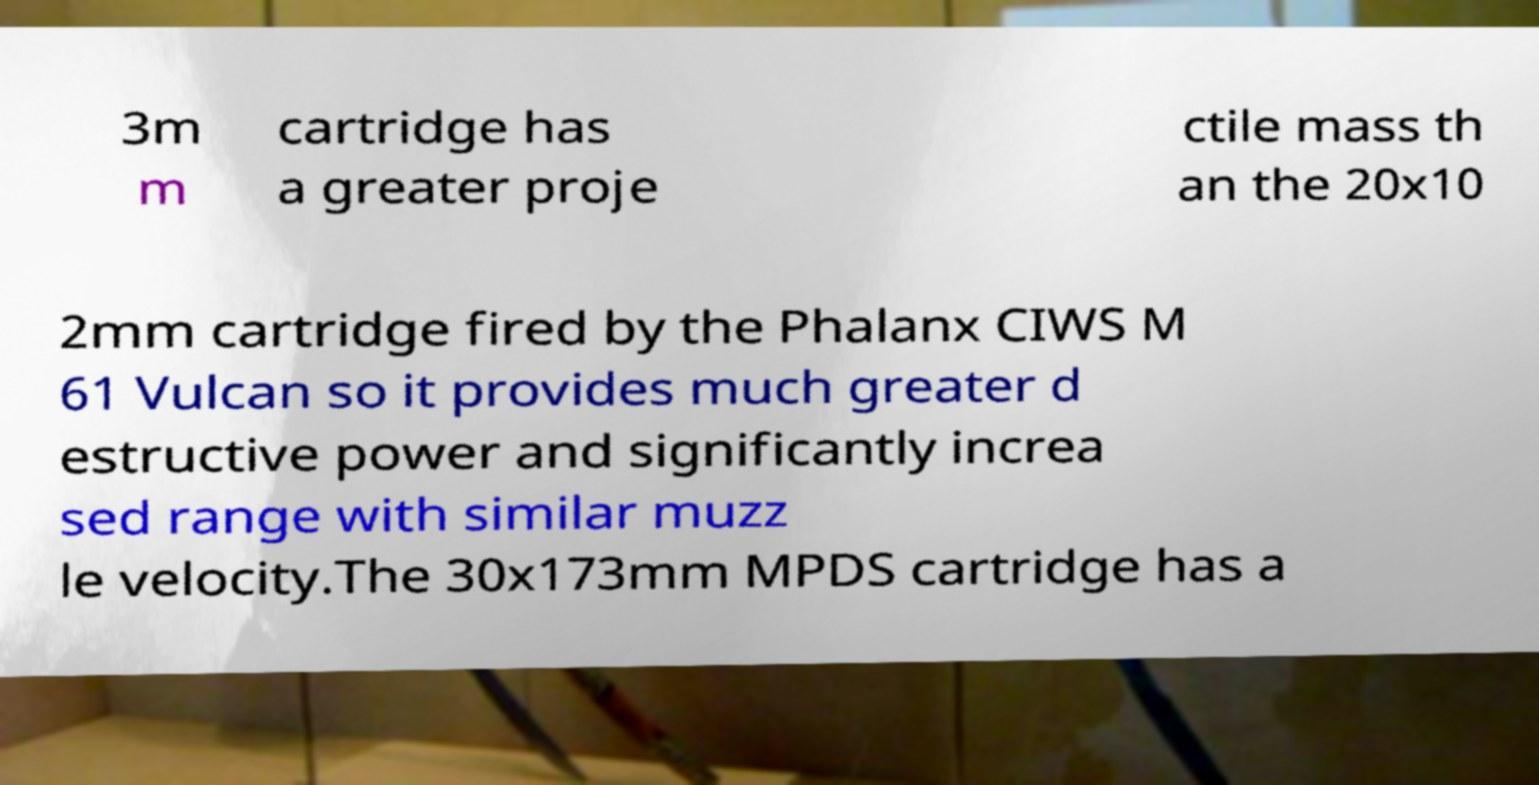Please identify and transcribe the text found in this image. 3m m cartridge has a greater proje ctile mass th an the 20x10 2mm cartridge fired by the Phalanx CIWS M 61 Vulcan so it provides much greater d estructive power and significantly increa sed range with similar muzz le velocity.The 30x173mm MPDS cartridge has a 